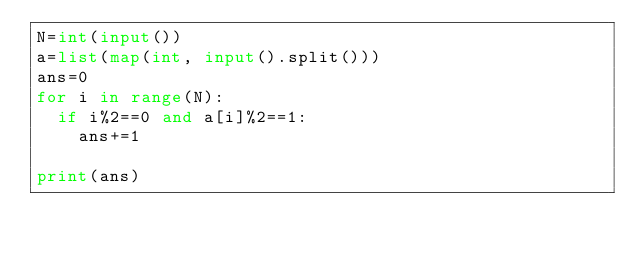Convert code to text. <code><loc_0><loc_0><loc_500><loc_500><_Python_>N=int(input())
a=list(map(int, input().split()))
ans=0
for i in range(N):
  if i%2==0 and a[i]%2==1:
    ans+=1
    
print(ans)</code> 